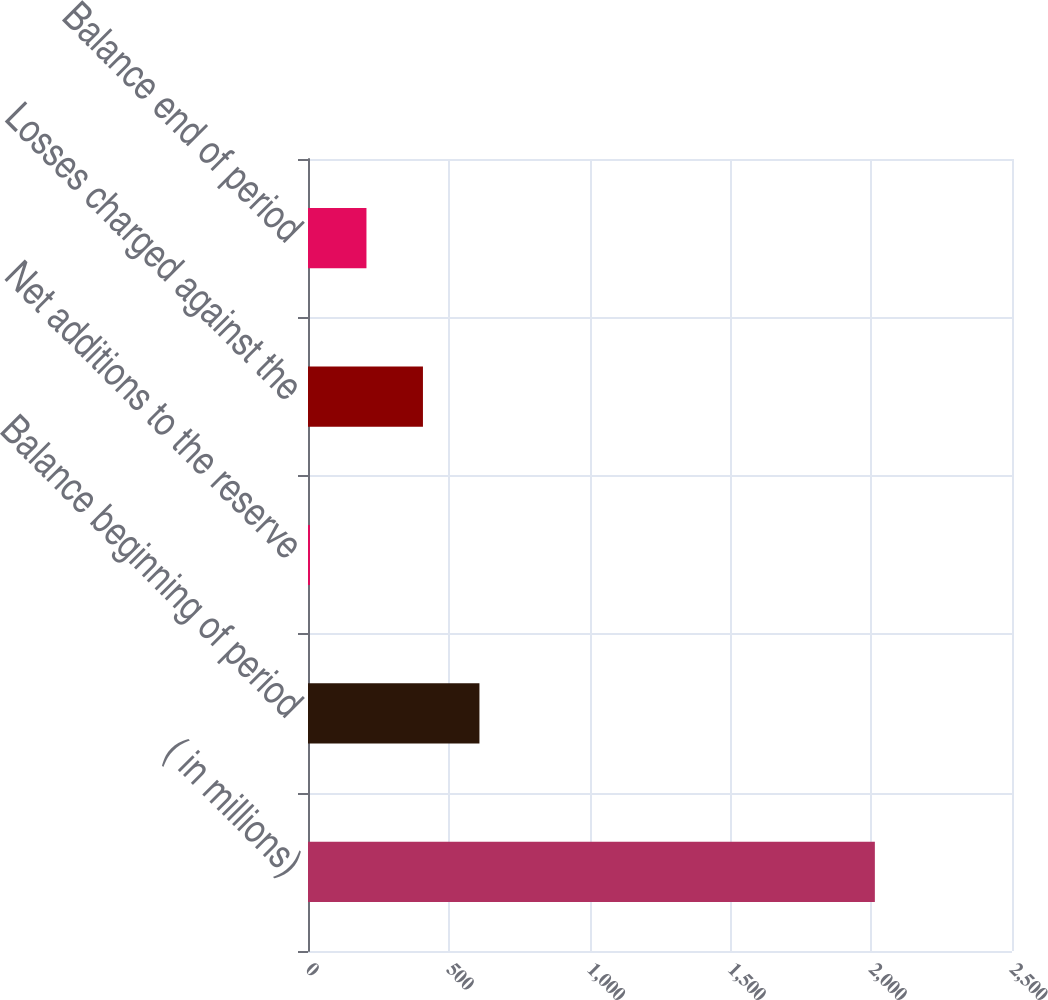<chart> <loc_0><loc_0><loc_500><loc_500><bar_chart><fcel>( in millions)<fcel>Balance beginning of period<fcel>Net additions to the reserve<fcel>Losses charged against the<fcel>Balance end of period<nl><fcel>2013<fcel>608.8<fcel>7<fcel>408.2<fcel>207.6<nl></chart> 